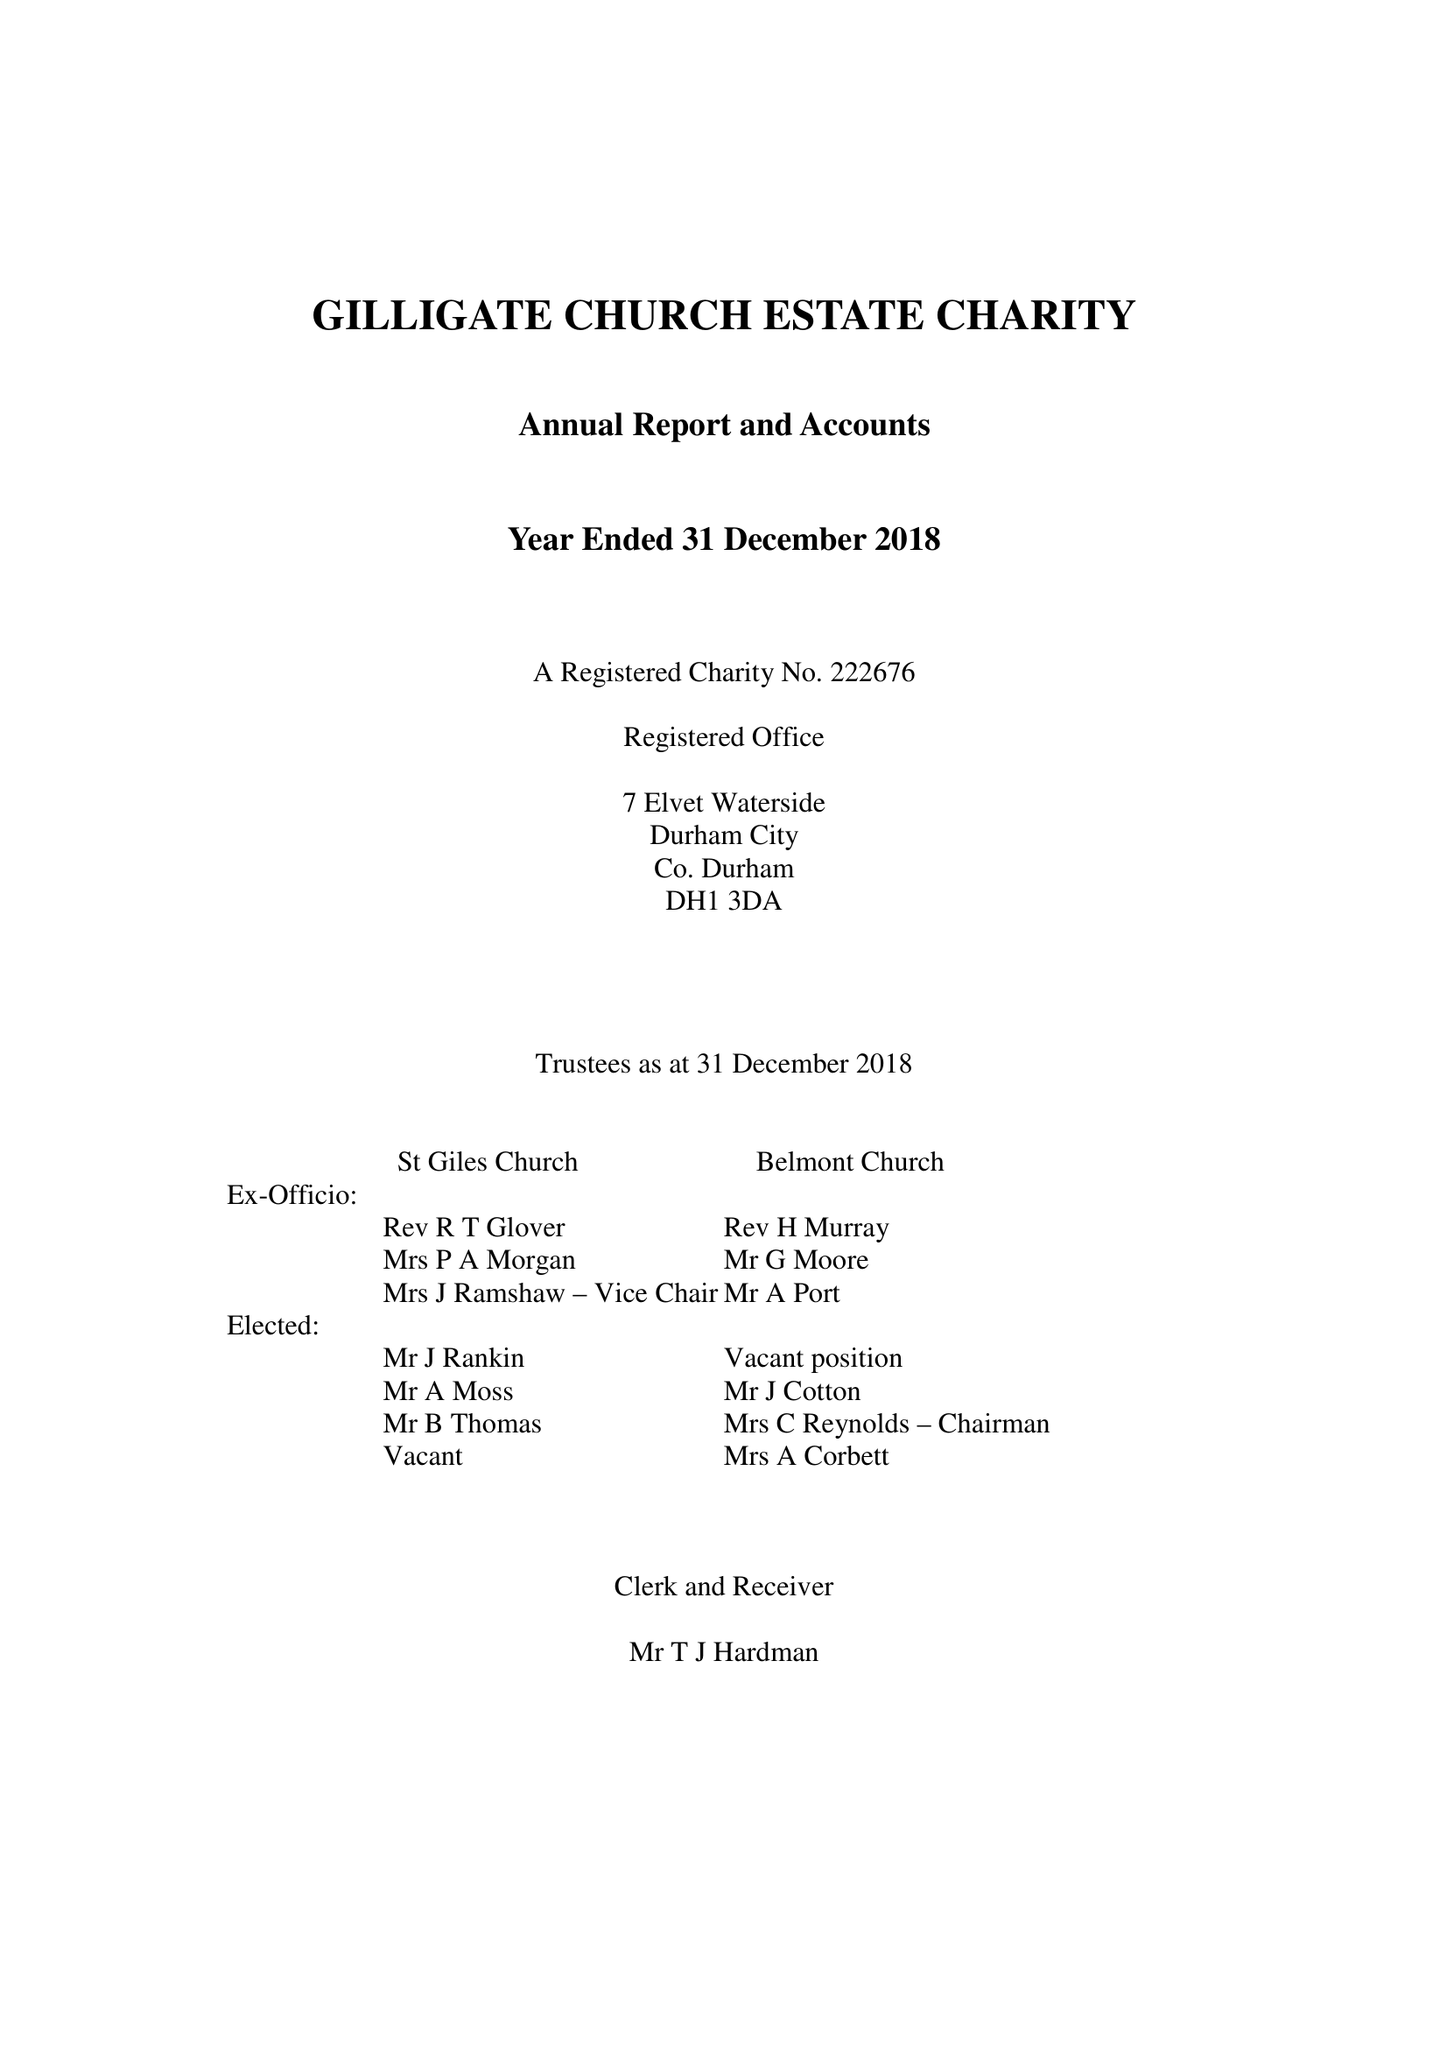What is the value for the income_annually_in_british_pounds?
Answer the question using a single word or phrase. 90855.00 